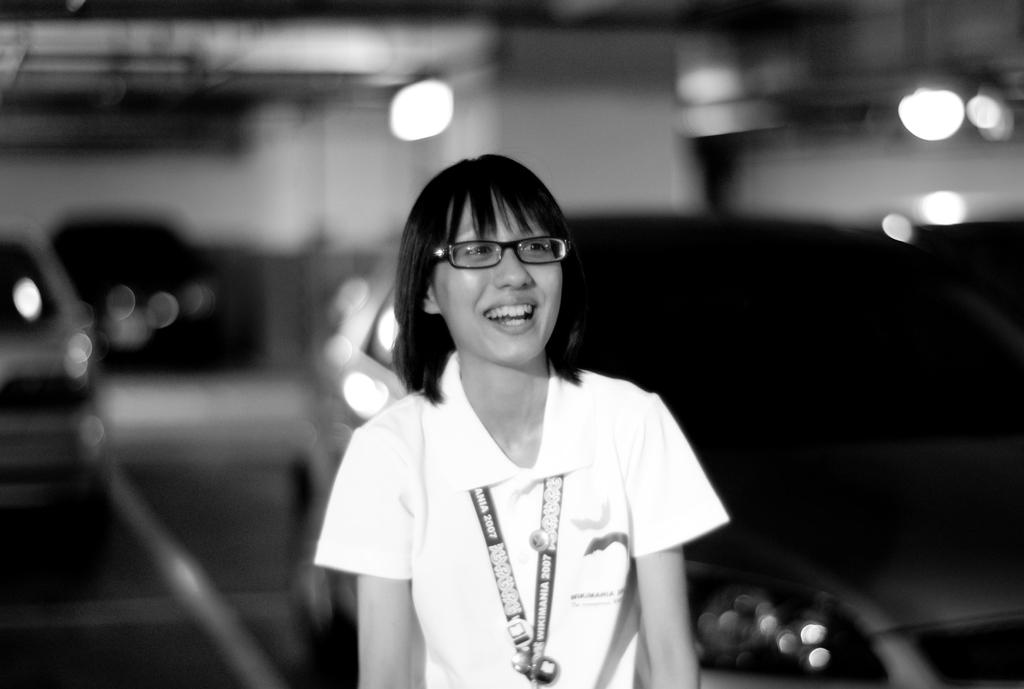Who is present in the image? There is a woman in the image. What is the woman wearing? The woman is wearing a white dress and spectacles. What can be seen in the background of the image? There is a wall in the image, and the background is slightly blurred. What other objects or elements are present in the image? There are lights and cars in the image. How many thumbs can be seen on the woman's hands in the image? There is no visible thumb on the woman's hands in the image, as only her dress and spectacles are clearly visible. 